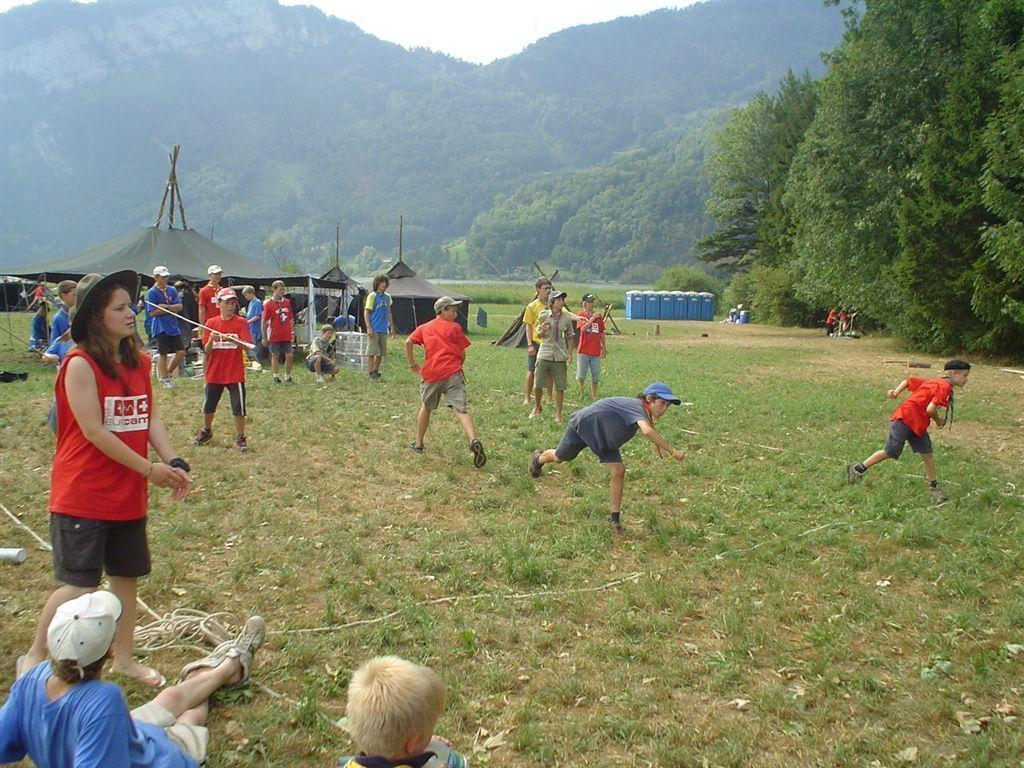What type of vegetation is present in the image? There is grass in the image. Can you describe the people in the image? There are people in the image. What can be seen in the background of the image? There are tents and trees in the background of the image. What type of metal is used to construct the skin of the people in the image? There is no mention of metal or skin in the image; the people are not described as having any metallic or artificial components. 